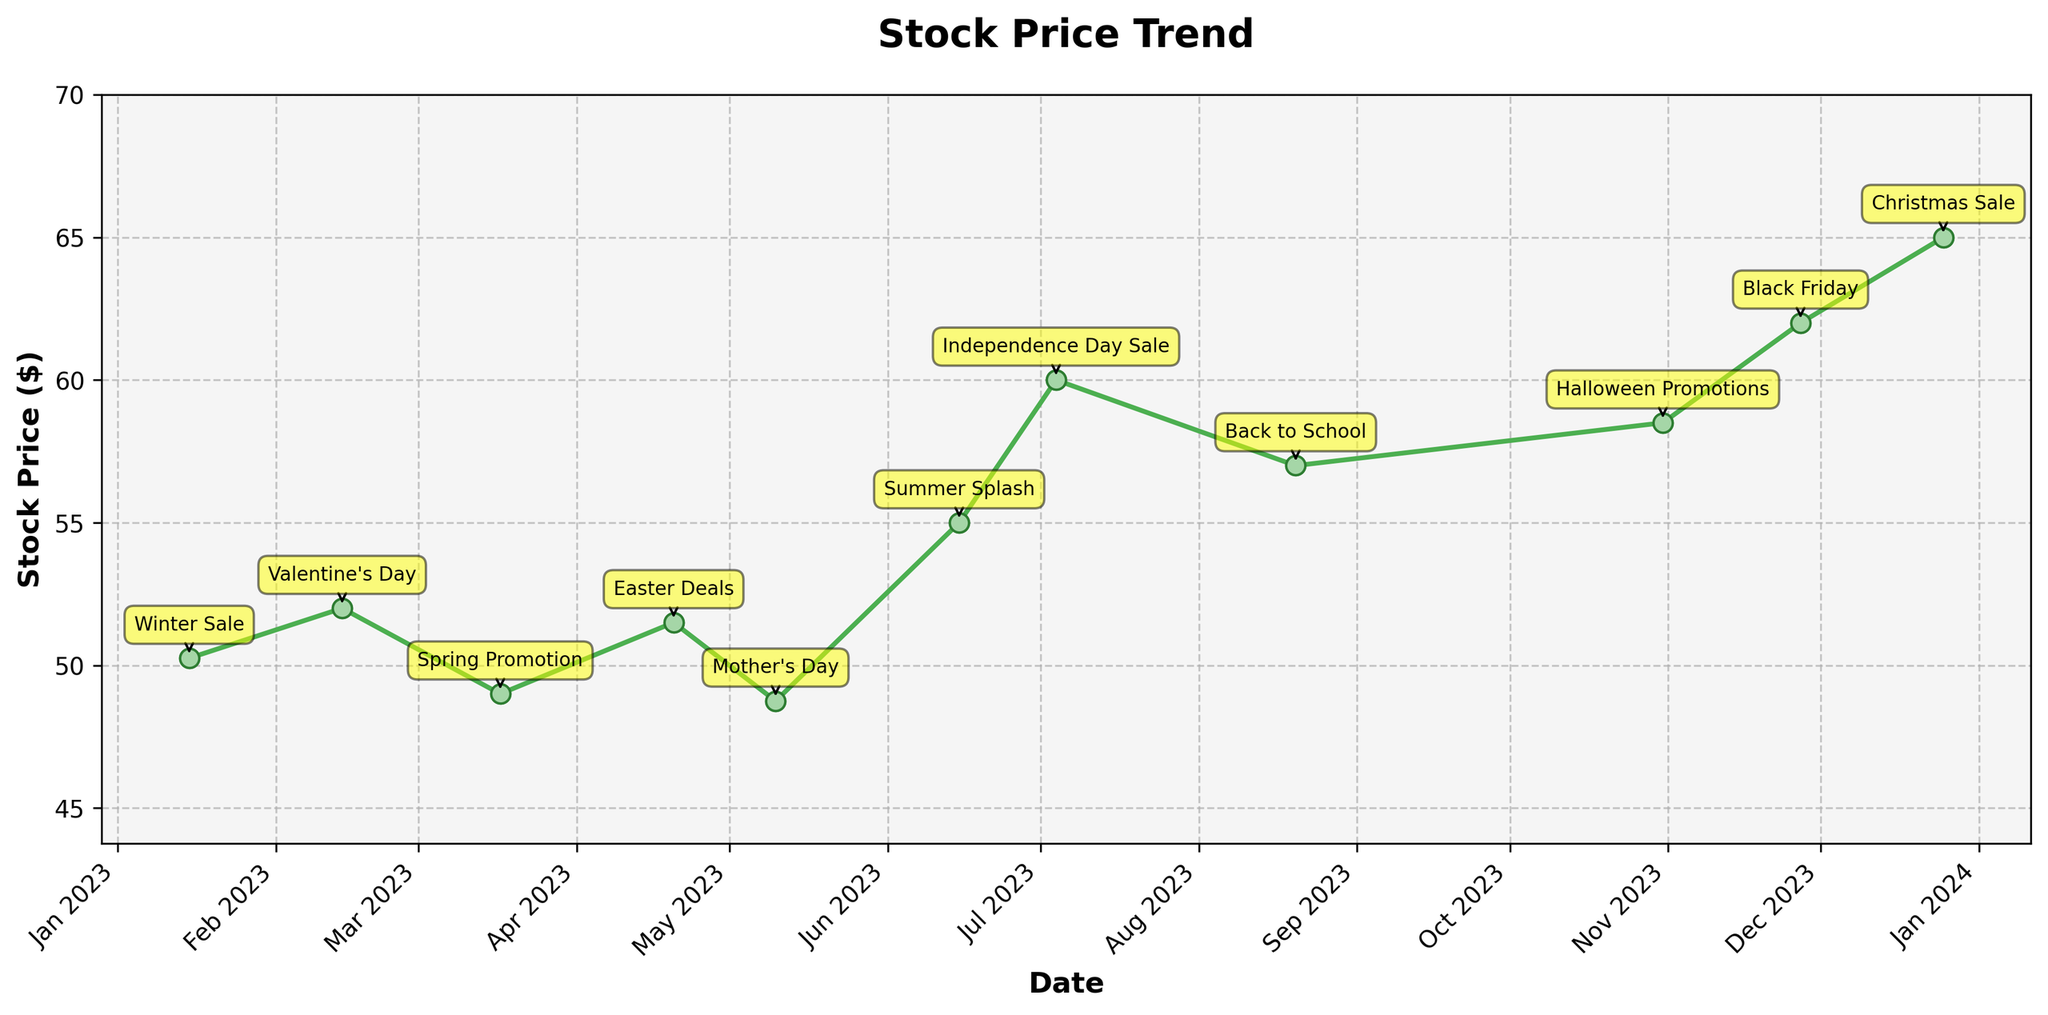what is the title of the figure? The title of a figure is typically located at the top and provides a brief summary of what the figure is about. In this case, it summarizes the overall trend of stock prices.
Answer: Stock Price Trend How many data points are plotted in the figure? To find the number of data points, you simply count the number of points indicated on the plot. Each date and corresponding stock price represent one data point.
Answer: 13 Which advertisement event corresponds to the highest stock price? To determine this, locate the highest stock price on the plot, then check the annotated event for that date. The highest stock price is $65.00.
Answer: Christmas Sale What is the lowest stock price and when did it occur? Identify the lowest point on the plot line, then check the corresponding date. The lowest stock price is $48.75.
Answer: May 10 How does the stock price on Halloween compare to Valentine's Day? Identify the stock prices on the dates corresponding to Halloween and Valentine's Day, then compare their values. Halloween stock price ($58.50) is higher than Valentine's Day ($52.00).
Answer: Higher on Halloween Which product category appears most frequently in the data? Check the listed data points and count the frequency each product category appears. Clothing appears the most frequently.
Answer: Clothing What is the difference between the stock price on Black Friday and Summer Splash? Find the stock prices on Black Friday ($62.00) and Summer Splash ($55.00), then calculate the difference. The difference is $62.00 - $55.00.
Answer: $7.00 Based on the plot, is there a general trend of increasing or decreasing stock prices towards the end of the year? Observe the stock price trajectory, particularly from the middle to the end of the year. The stock prices increase from the middle towards the end of the year.
Answer: Increasing What is the average stock price during the winter season (January to March)? Identify the stock prices in the winter months (January, February, March), then calculate the average. Winter season prices: $50.25, $52.00, $49.00. Average is ($50.25 + $52.00 + $49.00)/3.
Answer: $50.42 What advertising event had the stock price closest to $50? Locate the stock price closest to $50, then identify the corresponding event. The closest event is Winter Sale with a stock price of $50.25.
Answer: Winter Sale 